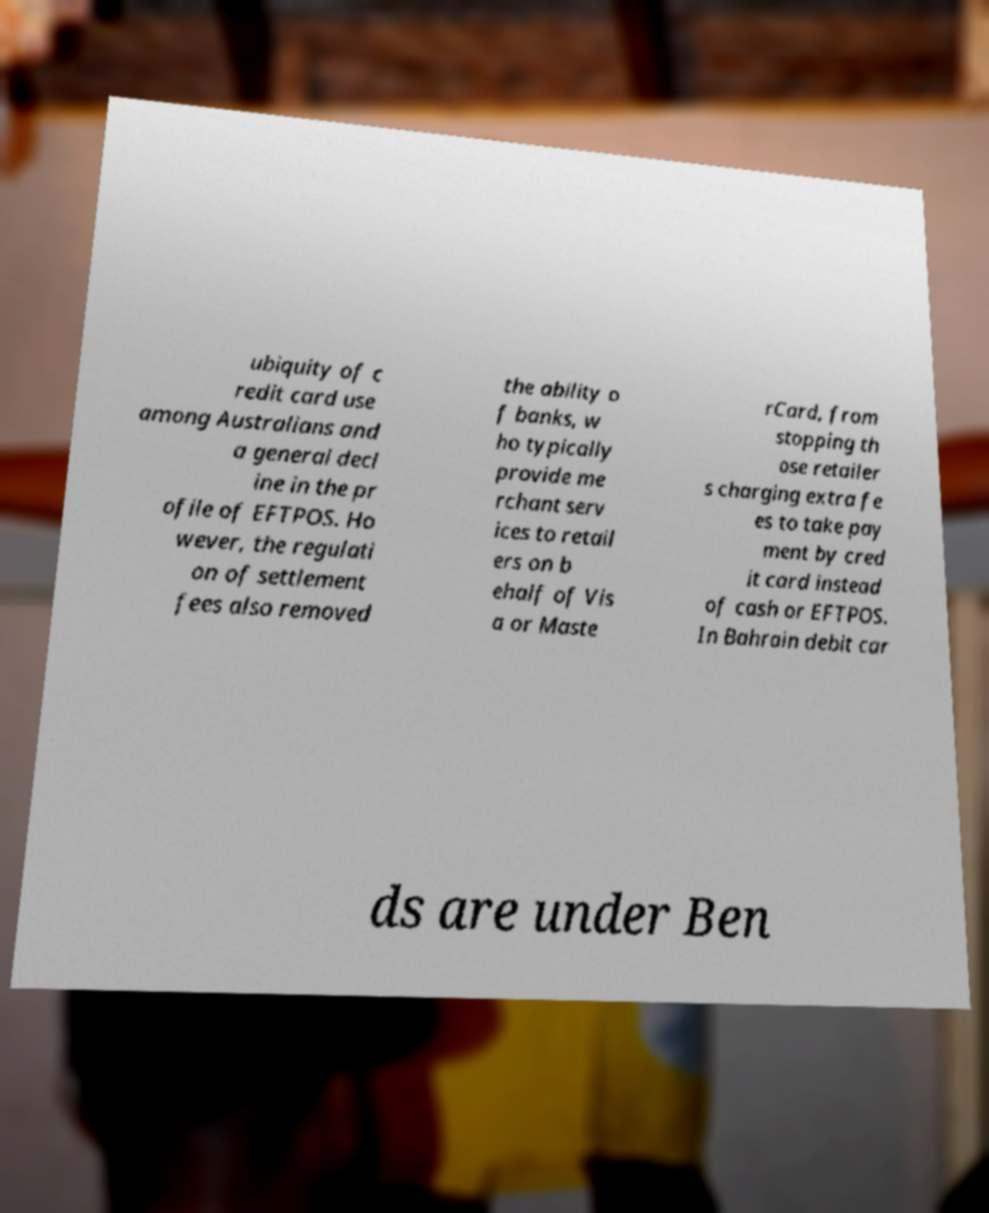Could you assist in decoding the text presented in this image and type it out clearly? ubiquity of c redit card use among Australians and a general decl ine in the pr ofile of EFTPOS. Ho wever, the regulati on of settlement fees also removed the ability o f banks, w ho typically provide me rchant serv ices to retail ers on b ehalf of Vis a or Maste rCard, from stopping th ose retailer s charging extra fe es to take pay ment by cred it card instead of cash or EFTPOS. In Bahrain debit car ds are under Ben 